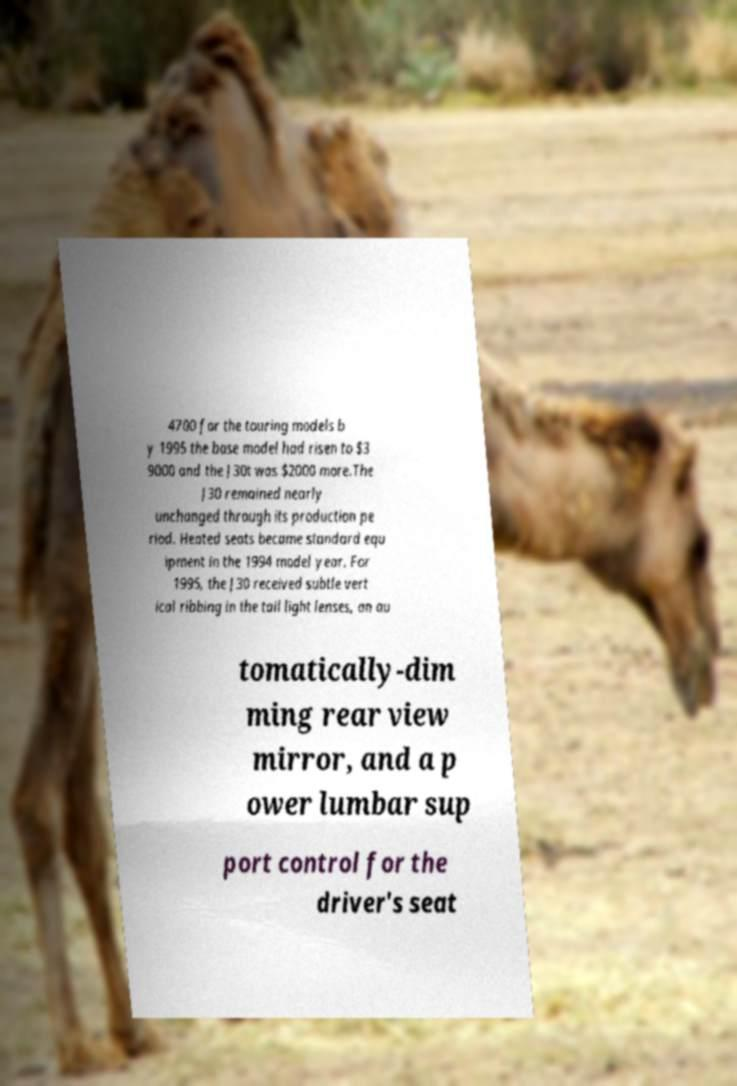Could you extract and type out the text from this image? 4700 for the touring models b y 1995 the base model had risen to $3 9000 and the J30t was $2000 more.The J30 remained nearly unchanged through its production pe riod. Heated seats became standard equ ipment in the 1994 model year. For 1995, the J30 received subtle vert ical ribbing in the tail light lenses, an au tomatically-dim ming rear view mirror, and a p ower lumbar sup port control for the driver's seat 